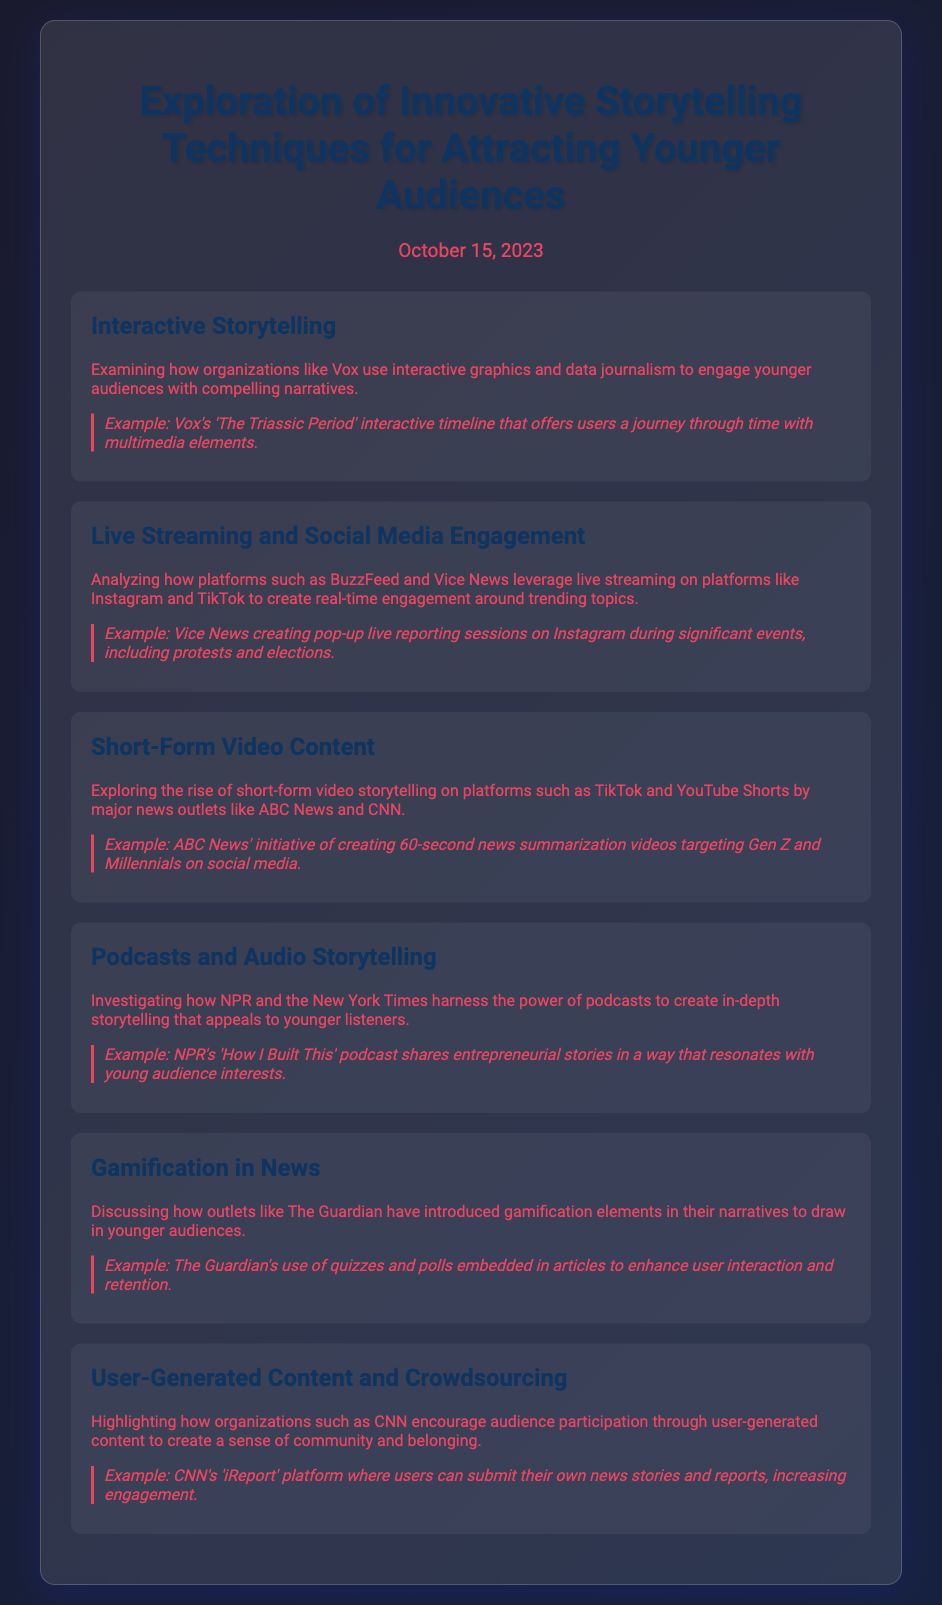What is the title of the agenda? The title is stated at the top of the document.
Answer: Exploration of Innovative Storytelling Techniques for Attracting Younger Audiences When was this document published? The date is mentioned directly below the title in the document.
Answer: October 15, 2023 Which organization uses interactive storytelling techniques? This information can be found in the section regarding interactive storytelling.
Answer: Vox What type of content does ABC News create for younger audiences? The document describes a specific initiative by ABC News.
Answer: 60-second news summarization videos What is one platform where live streaming is utilized? The document mentions specific platforms for live streaming engagement.
Answer: Instagram Which news organization harnesses podcasts for storytelling? This is found in the section discussing audio storytelling.
Answer: NPR What unique method does The Guardian use to engage younger audiences? The document outlines specific elements introduced by The Guardian.
Answer: Gamification Which news organization's platform allows user-generated stories? The document highlights a specific platform for audience participation.
Answer: CNN 